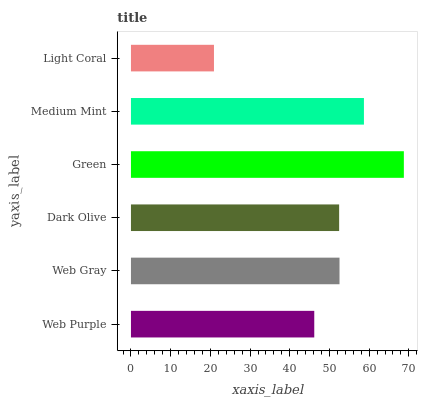Is Light Coral the minimum?
Answer yes or no. Yes. Is Green the maximum?
Answer yes or no. Yes. Is Web Gray the minimum?
Answer yes or no. No. Is Web Gray the maximum?
Answer yes or no. No. Is Web Gray greater than Web Purple?
Answer yes or no. Yes. Is Web Purple less than Web Gray?
Answer yes or no. Yes. Is Web Purple greater than Web Gray?
Answer yes or no. No. Is Web Gray less than Web Purple?
Answer yes or no. No. Is Web Gray the high median?
Answer yes or no. Yes. Is Dark Olive the low median?
Answer yes or no. Yes. Is Light Coral the high median?
Answer yes or no. No. Is Web Gray the low median?
Answer yes or no. No. 